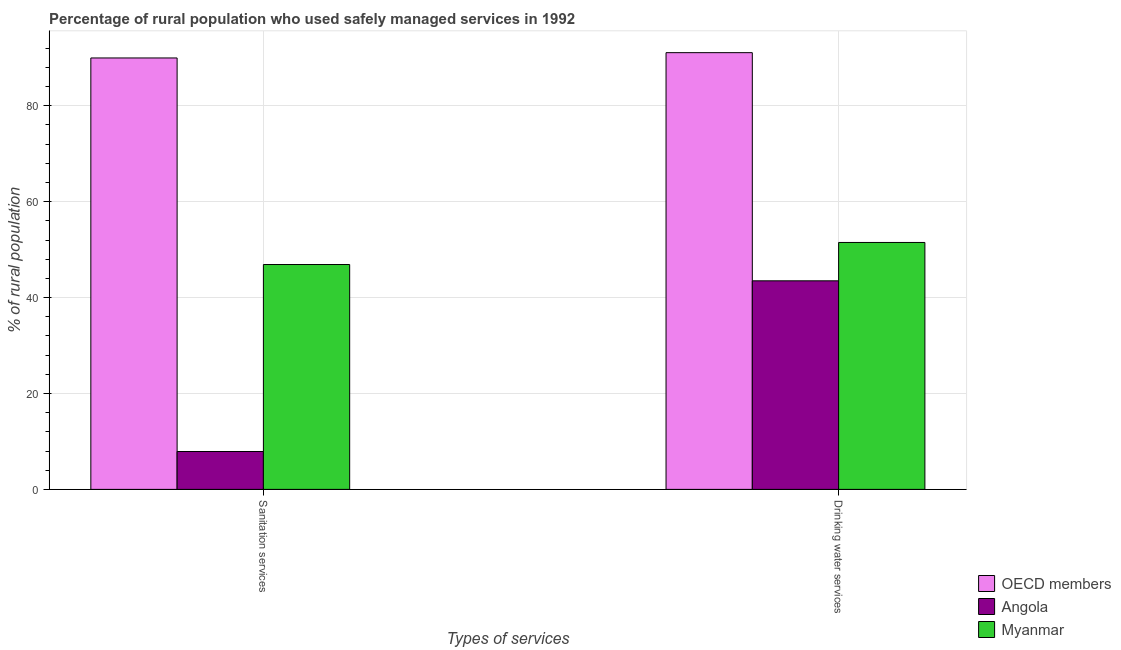How many different coloured bars are there?
Make the answer very short. 3. How many bars are there on the 2nd tick from the left?
Provide a succinct answer. 3. How many bars are there on the 1st tick from the right?
Offer a terse response. 3. What is the label of the 2nd group of bars from the left?
Your answer should be very brief. Drinking water services. What is the percentage of rural population who used drinking water services in Angola?
Your response must be concise. 43.5. Across all countries, what is the maximum percentage of rural population who used sanitation services?
Keep it short and to the point. 89.98. In which country was the percentage of rural population who used drinking water services minimum?
Make the answer very short. Angola. What is the total percentage of rural population who used sanitation services in the graph?
Offer a very short reply. 144.78. What is the difference between the percentage of rural population who used drinking water services in Myanmar and that in Angola?
Your answer should be very brief. 8. What is the difference between the percentage of rural population who used sanitation services in Myanmar and the percentage of rural population who used drinking water services in Angola?
Your response must be concise. 3.4. What is the average percentage of rural population who used sanitation services per country?
Give a very brief answer. 48.26. What is the difference between the percentage of rural population who used drinking water services and percentage of rural population who used sanitation services in Angola?
Ensure brevity in your answer.  35.6. In how many countries, is the percentage of rural population who used drinking water services greater than 76 %?
Provide a succinct answer. 1. What is the ratio of the percentage of rural population who used drinking water services in Myanmar to that in OECD members?
Your response must be concise. 0.57. What does the 2nd bar from the left in Drinking water services represents?
Give a very brief answer. Angola. What does the 1st bar from the right in Drinking water services represents?
Your answer should be very brief. Myanmar. Are all the bars in the graph horizontal?
Give a very brief answer. No. Are the values on the major ticks of Y-axis written in scientific E-notation?
Give a very brief answer. No. Does the graph contain any zero values?
Make the answer very short. No. Does the graph contain grids?
Offer a terse response. Yes. Where does the legend appear in the graph?
Your response must be concise. Bottom right. How are the legend labels stacked?
Give a very brief answer. Vertical. What is the title of the graph?
Ensure brevity in your answer.  Percentage of rural population who used safely managed services in 1992. What is the label or title of the X-axis?
Offer a terse response. Types of services. What is the label or title of the Y-axis?
Provide a succinct answer. % of rural population. What is the % of rural population of OECD members in Sanitation services?
Provide a succinct answer. 89.98. What is the % of rural population of Angola in Sanitation services?
Your answer should be compact. 7.9. What is the % of rural population of Myanmar in Sanitation services?
Ensure brevity in your answer.  46.9. What is the % of rural population in OECD members in Drinking water services?
Keep it short and to the point. 91.08. What is the % of rural population in Angola in Drinking water services?
Make the answer very short. 43.5. What is the % of rural population of Myanmar in Drinking water services?
Ensure brevity in your answer.  51.5. Across all Types of services, what is the maximum % of rural population in OECD members?
Your response must be concise. 91.08. Across all Types of services, what is the maximum % of rural population of Angola?
Give a very brief answer. 43.5. Across all Types of services, what is the maximum % of rural population of Myanmar?
Offer a very short reply. 51.5. Across all Types of services, what is the minimum % of rural population in OECD members?
Your answer should be very brief. 89.98. Across all Types of services, what is the minimum % of rural population in Myanmar?
Your answer should be very brief. 46.9. What is the total % of rural population of OECD members in the graph?
Make the answer very short. 181.07. What is the total % of rural population in Angola in the graph?
Your answer should be compact. 51.4. What is the total % of rural population in Myanmar in the graph?
Provide a short and direct response. 98.4. What is the difference between the % of rural population in OECD members in Sanitation services and that in Drinking water services?
Give a very brief answer. -1.1. What is the difference between the % of rural population in Angola in Sanitation services and that in Drinking water services?
Keep it short and to the point. -35.6. What is the difference between the % of rural population in Myanmar in Sanitation services and that in Drinking water services?
Your response must be concise. -4.6. What is the difference between the % of rural population in OECD members in Sanitation services and the % of rural population in Angola in Drinking water services?
Keep it short and to the point. 46.48. What is the difference between the % of rural population of OECD members in Sanitation services and the % of rural population of Myanmar in Drinking water services?
Your answer should be compact. 38.48. What is the difference between the % of rural population of Angola in Sanitation services and the % of rural population of Myanmar in Drinking water services?
Give a very brief answer. -43.6. What is the average % of rural population in OECD members per Types of services?
Keep it short and to the point. 90.53. What is the average % of rural population of Angola per Types of services?
Provide a short and direct response. 25.7. What is the average % of rural population of Myanmar per Types of services?
Your response must be concise. 49.2. What is the difference between the % of rural population in OECD members and % of rural population in Angola in Sanitation services?
Keep it short and to the point. 82.08. What is the difference between the % of rural population in OECD members and % of rural population in Myanmar in Sanitation services?
Your response must be concise. 43.08. What is the difference between the % of rural population of Angola and % of rural population of Myanmar in Sanitation services?
Your response must be concise. -39. What is the difference between the % of rural population of OECD members and % of rural population of Angola in Drinking water services?
Your response must be concise. 47.59. What is the difference between the % of rural population in OECD members and % of rural population in Myanmar in Drinking water services?
Your answer should be compact. 39.59. What is the difference between the % of rural population in Angola and % of rural population in Myanmar in Drinking water services?
Provide a succinct answer. -8. What is the ratio of the % of rural population of OECD members in Sanitation services to that in Drinking water services?
Make the answer very short. 0.99. What is the ratio of the % of rural population of Angola in Sanitation services to that in Drinking water services?
Offer a very short reply. 0.18. What is the ratio of the % of rural population of Myanmar in Sanitation services to that in Drinking water services?
Offer a very short reply. 0.91. What is the difference between the highest and the second highest % of rural population in OECD members?
Give a very brief answer. 1.1. What is the difference between the highest and the second highest % of rural population in Angola?
Offer a terse response. 35.6. What is the difference between the highest and the lowest % of rural population in OECD members?
Your response must be concise. 1.1. What is the difference between the highest and the lowest % of rural population in Angola?
Give a very brief answer. 35.6. 